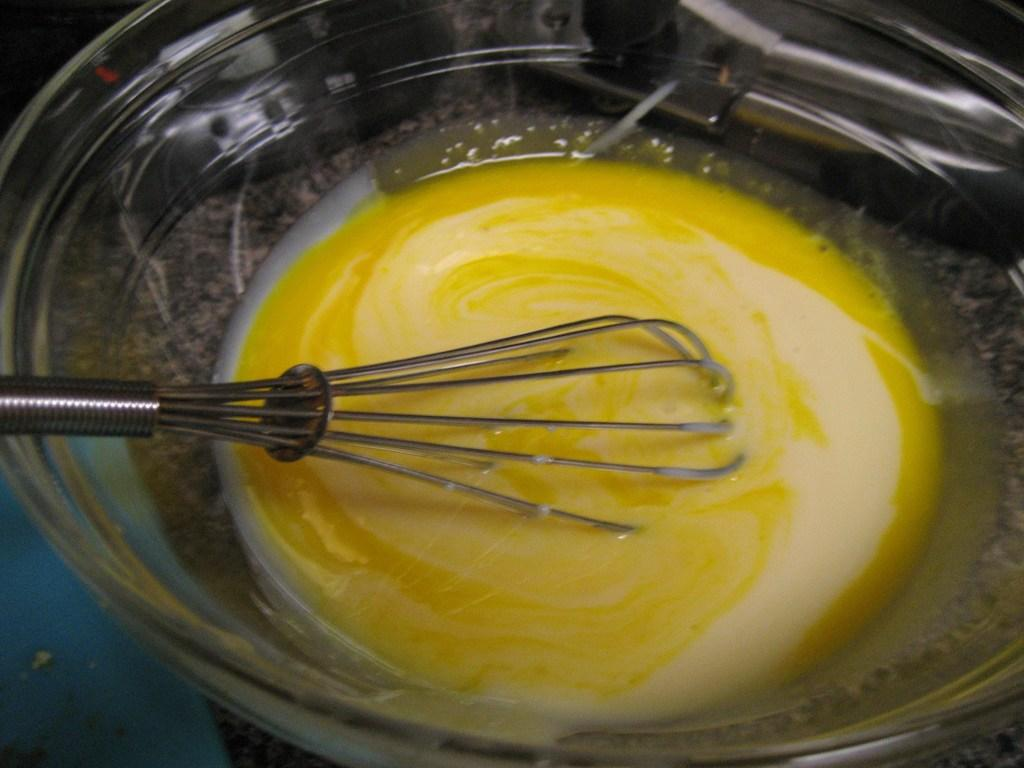What is in the glass bowl that is visible in the image? The glass bowl contains liquid egg. What is being used to mix the liquid egg in the glass bowl? There is a whisker in the glass bowl. Where is the glass bowl located in the image? The glass bowl is placed on a table. What can be observed about the lighting in the image? The top left corner of the image appears to be dark. Can you see any goat's feet in the image? There are no goat's feet present in the image. What type of edge is visible in the image? The image does not show any specific edges; it is a picture of a glass bowl containing liquid egg with a whisker. 